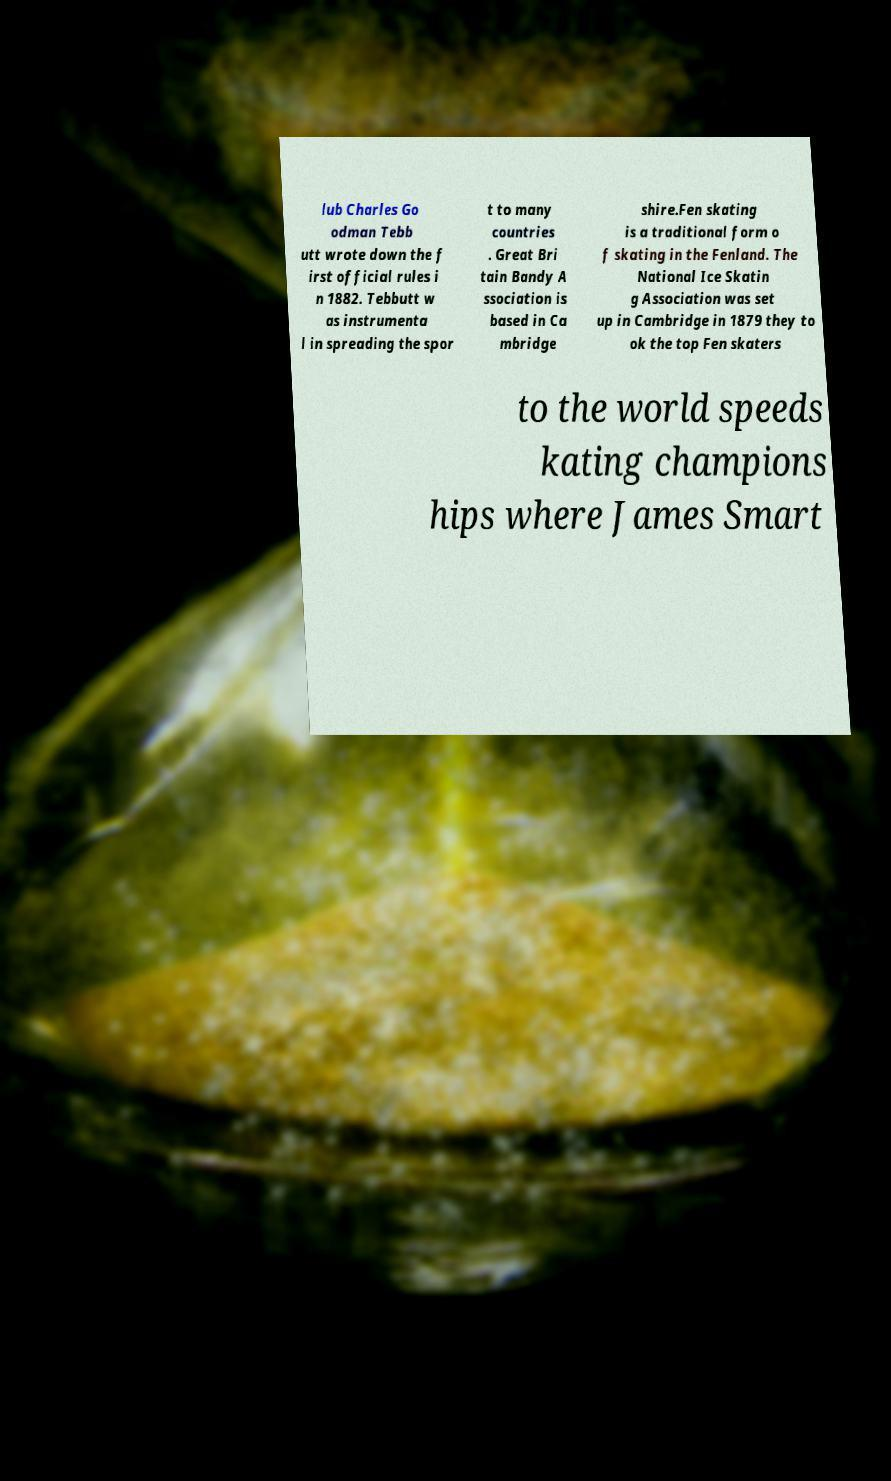Can you read and provide the text displayed in the image?This photo seems to have some interesting text. Can you extract and type it out for me? lub Charles Go odman Tebb utt wrote down the f irst official rules i n 1882. Tebbutt w as instrumenta l in spreading the spor t to many countries . Great Bri tain Bandy A ssociation is based in Ca mbridge shire.Fen skating is a traditional form o f skating in the Fenland. The National Ice Skatin g Association was set up in Cambridge in 1879 they to ok the top Fen skaters to the world speeds kating champions hips where James Smart 